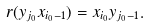Convert formula to latex. <formula><loc_0><loc_0><loc_500><loc_500>r ( y _ { j _ { 0 } } x _ { i _ { 0 } - 1 } ) = x _ { i _ { 0 } } y _ { j _ { 0 } - 1 } .</formula> 